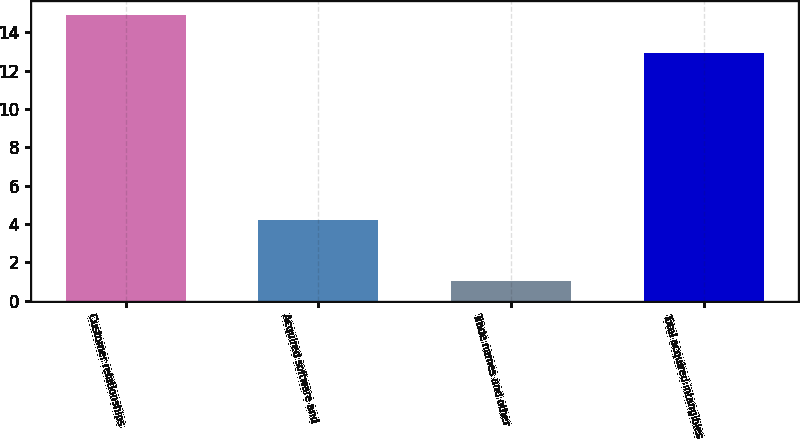Convert chart. <chart><loc_0><loc_0><loc_500><loc_500><bar_chart><fcel>Customer relationships<fcel>Acquired software and<fcel>Trade names and other<fcel>Total acquired intangibles<nl><fcel>14.9<fcel>4.2<fcel>1<fcel>12.9<nl></chart> 